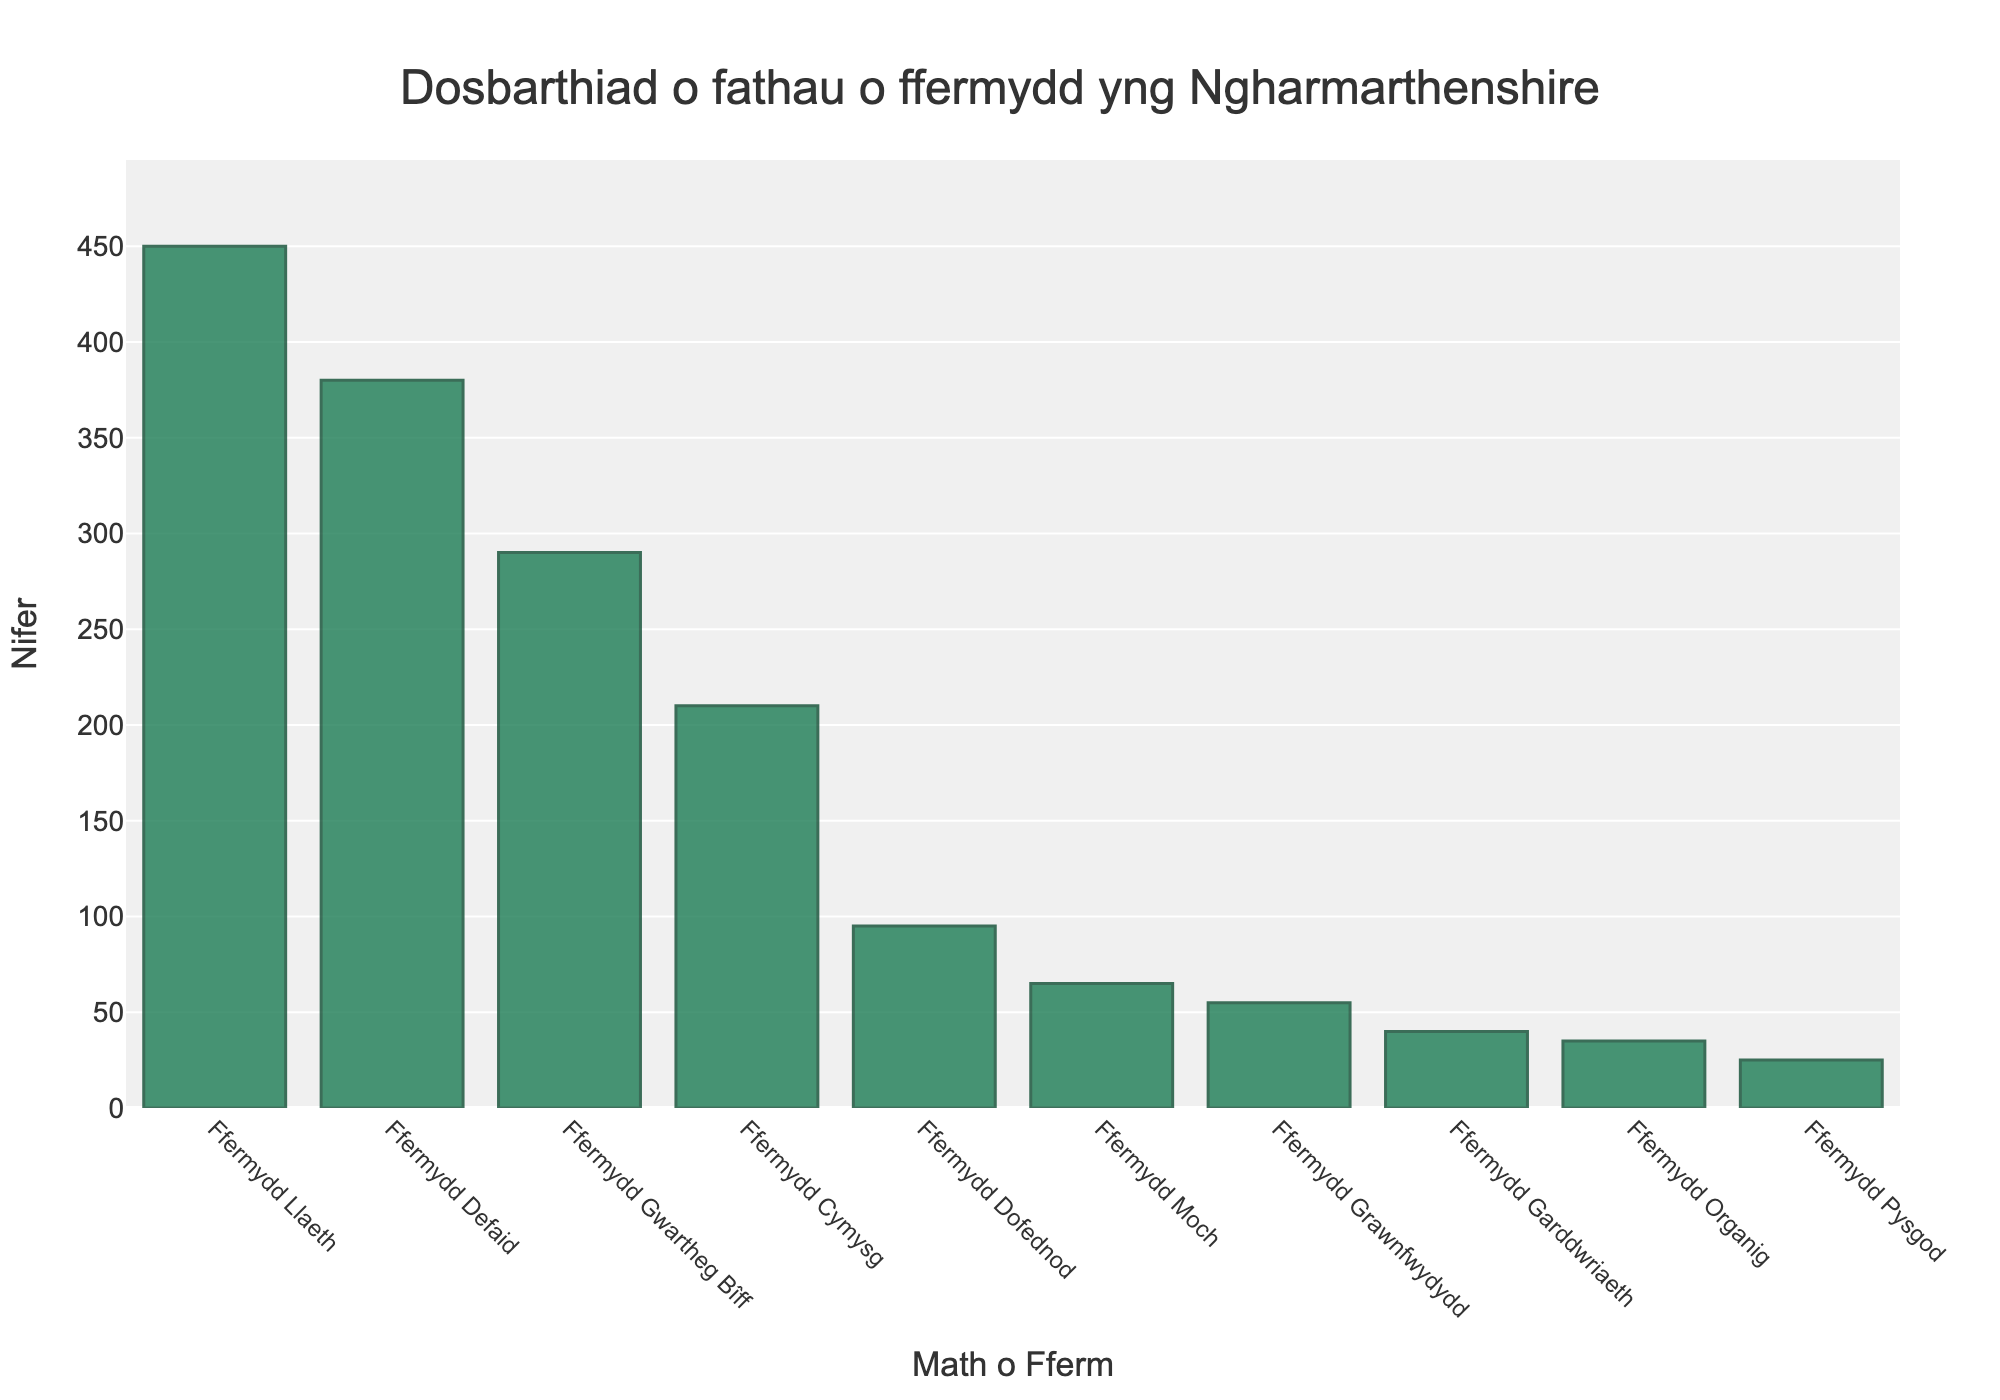Pa fath o fferm sydd â'r nifer fwyaf yng Ngharmarthenshire? Trwy edrych ar y darlun cynrychiolir gan farrau ar y graff sy'n dangos data ffermydd yng Ngharmarthenshire, gwelir fod Ffermydd Llaeth yn cael y nifer uchaf gyda 450 ffermydd.
Answer: Ffermydd Llaeth Pa fath o fferm sydd â'r nifer lleiaf? Trwy edrych ar y darlun cynrychiolir gan farrau ar y graff, ymddengys mai Ffermydd Pysgod sydd â'r nifer lleiaf gyda 25 ffermydd.
Answer: Ffermydd Pysgod Beth yw cyfanswm y nifer o Ffermydd Gwartheg Bîff, Ffermydd Cymysg, a Ffermydd Dofednod? Yn ôl y graff, mae gan Ffermydd Gwartheg Bîff 290 ffermydd, Ffermydd Cymysg 210 ffermydd, a Ffermydd Dofednod 95 ffermydd. Y cyfanswm yw 290 + 210 + 95 = 595.
Answer: 595 Pa fath o fferm sydd â mwy o ffermydd: Ffermydd Organig neu Ffermydd Garddwriaeth? Trwy edrych ar y graff, mae Ffermydd Garddwriaeth â 40 ffermydd tra bod Ffermydd Organig â 35 ffermydd. Felly mae Ffermydd Garddwriaeth â'r nifer fwyaf.
Answer: Ffermydd Garddwriaeth Pa mor uchel yw'r bar ar gyfer Ffermydd Defaid mewn cymhariaeth â'r bar ar gyfer Ffermydd Gwartheg Bîff? Trwy edrych ar daldra'r bariau yn y graff, mae'r bar ar gyfer Ffermydd Defaid yn uwch gyda 380 ffermydd o'i gymharu â Ffermydd Gwartheg Bîff sydd â 290.
Answer: Ffermydd Defaid yn uwch Beth yw'r gyfran o Ffermydd Defaid o'r cyfanswm o bob math o ffermydd? Cyfanswm y nifer o ffermydd yw 450 (Llaeth) + 380 (Defaid) + 290 (Gwartheg Bîff) + 210 (Cymysg) + 95 (Dofednod) + 65 (Moch) + 55 (Grawnfwydydd) + 40 (Garddwriaeth) + 35 (Organig) + 25 (Pysgod) = 1645. Y gyfran ar gyfer Ffermydd Defaid yw 380/1645 ≈ 0.231.
Answer: 23.1% Pa fathau o ffermydd sydd â llai na 100 ffermydd? Yn ôl y graff, y mathau o ffermydd sydd â llai na 100 ffermydd yw Ffermydd Dofednod (95), Ffermydd Moch (65), Ffermydd Grawnfwydydd (55), Ffermydd Garddwriaeth (40), Ffermydd Organig (35), a Ffermydd Pysgod (25).
Answer: Ffermydd Dofednod, Ffermydd Moch, Ffermydd Grawnfwydydd, Ffermydd Garddwriaeth, Ffermydd Organig, Ffermydd Pysgod 